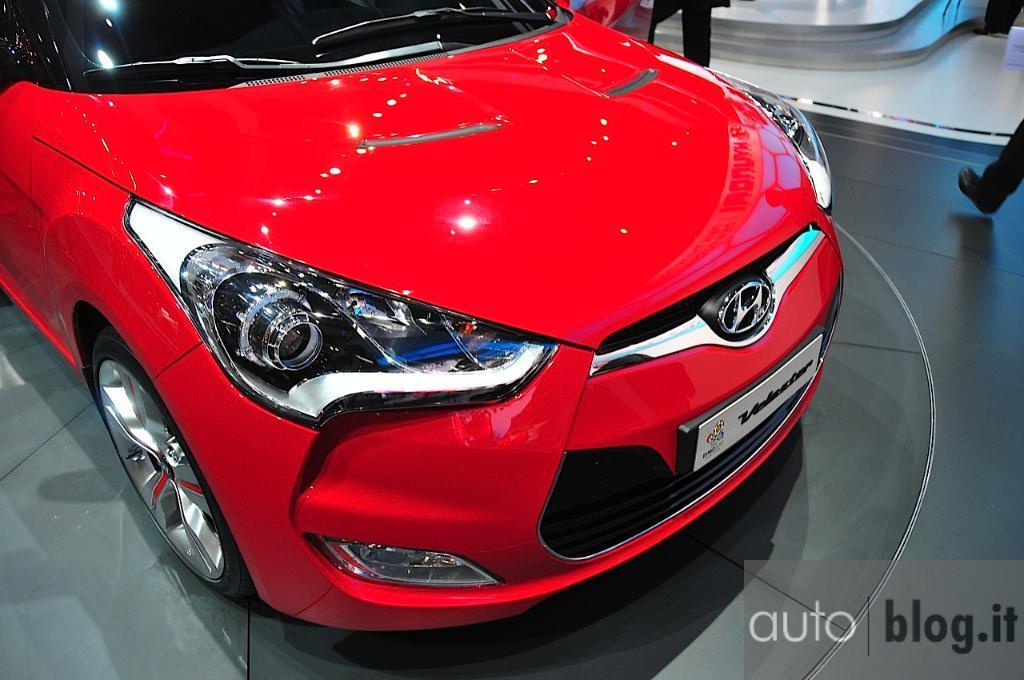Please provide a concise description of this image. In this image, I can see a car, which is red in color. This is a logo and a board, which are attached to the car. On the right side of the image, I can see a person's leg. This is the watermark on the image. 